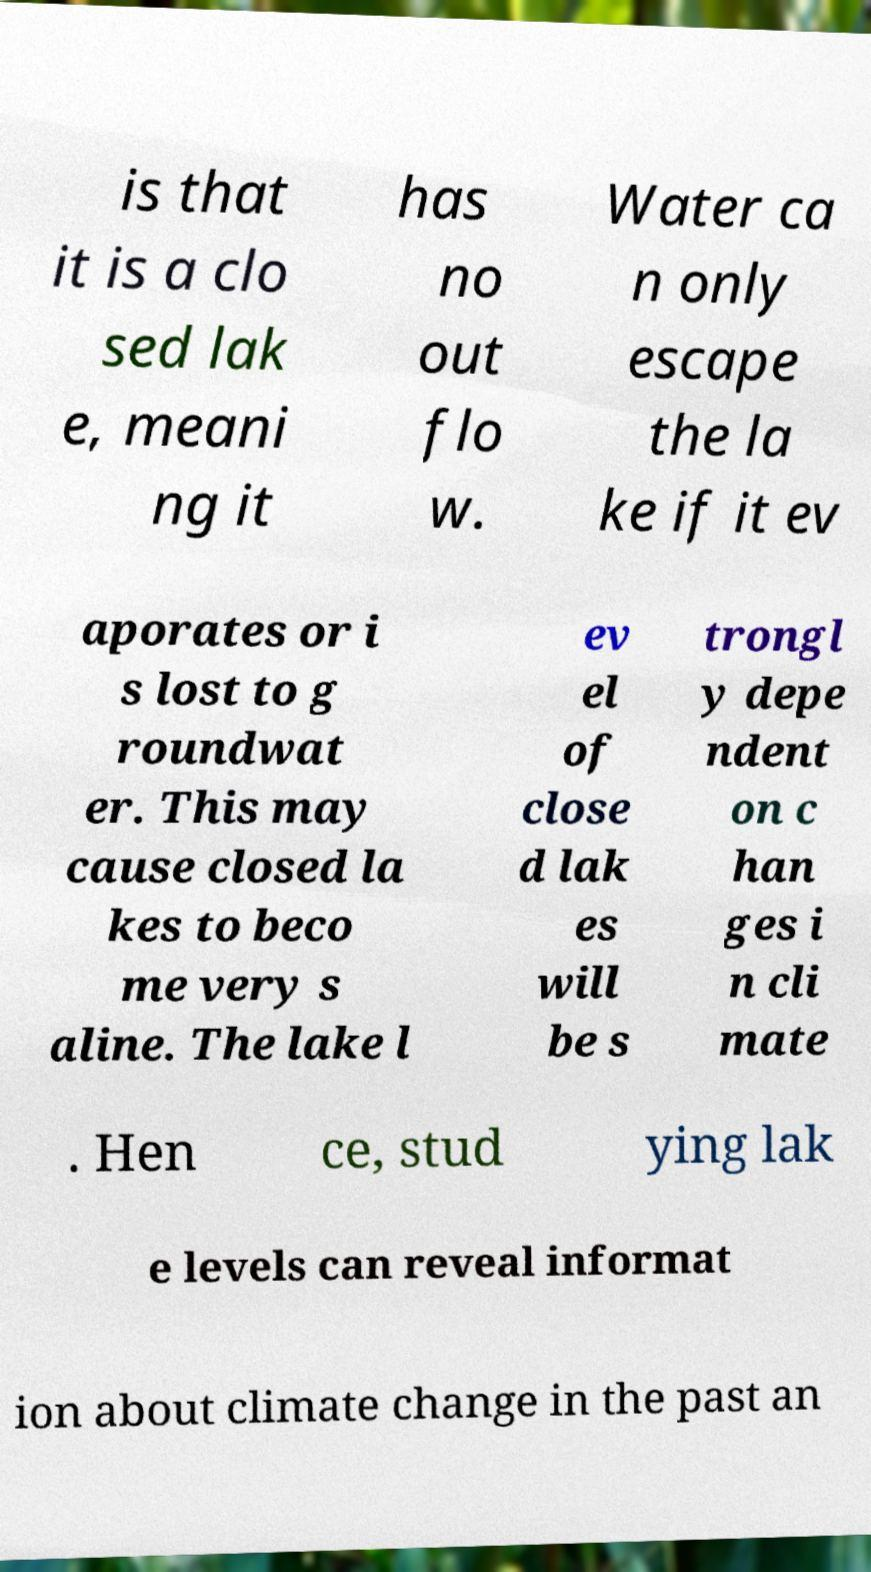Can you accurately transcribe the text from the provided image for me? is that it is a clo sed lak e, meani ng it has no out flo w. Water ca n only escape the la ke if it ev aporates or i s lost to g roundwat er. This may cause closed la kes to beco me very s aline. The lake l ev el of close d lak es will be s trongl y depe ndent on c han ges i n cli mate . Hen ce, stud ying lak e levels can reveal informat ion about climate change in the past an 